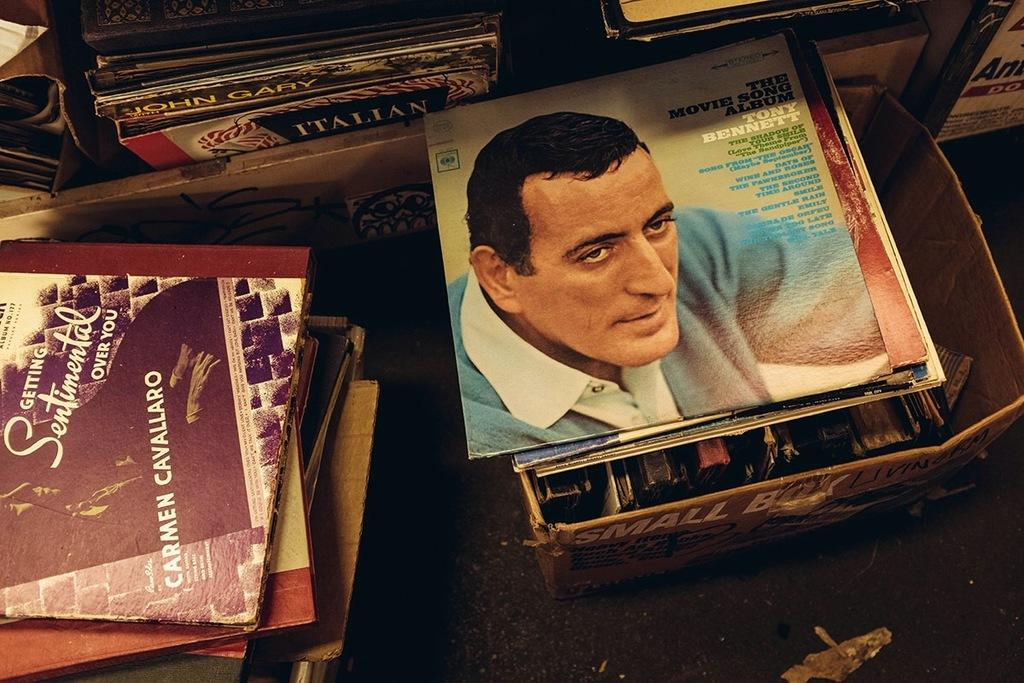<image>
Share a concise interpretation of the image provided. A variety of records including one by Tony Bennet, the Movie Song Album. 